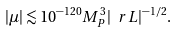<formula> <loc_0><loc_0><loc_500><loc_500>| \mu | \lesssim 1 0 ^ { - 1 2 0 } M _ { P } ^ { 3 } | \ r L | ^ { - 1 / 2 } .</formula> 